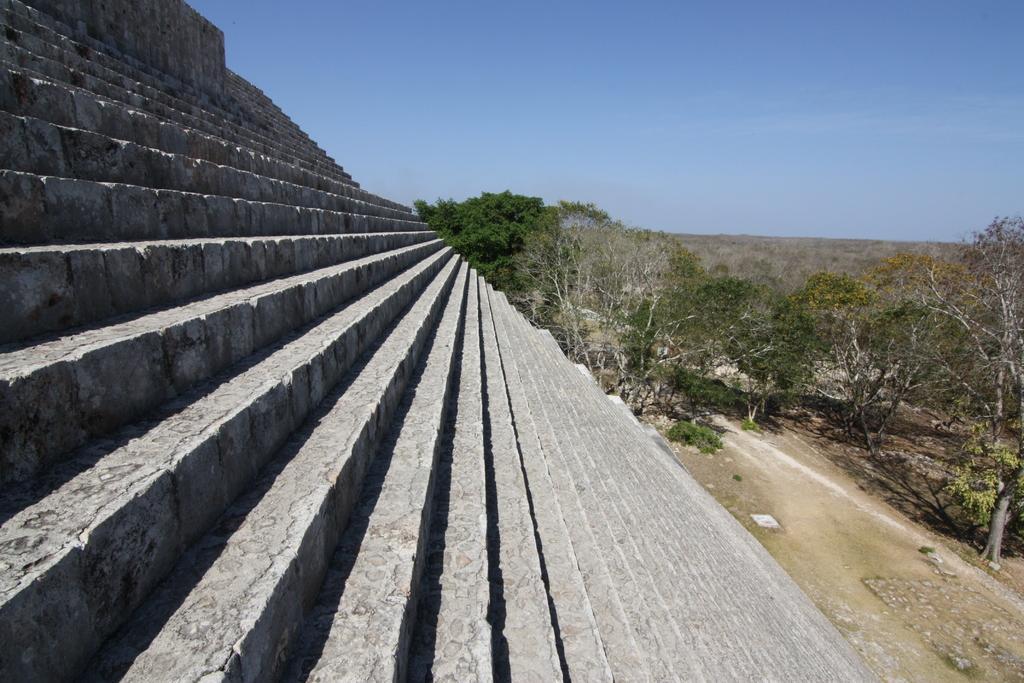In one or two sentences, can you explain what this image depicts? In this image we can see steps. Also there are trees. In the background there is sky. 